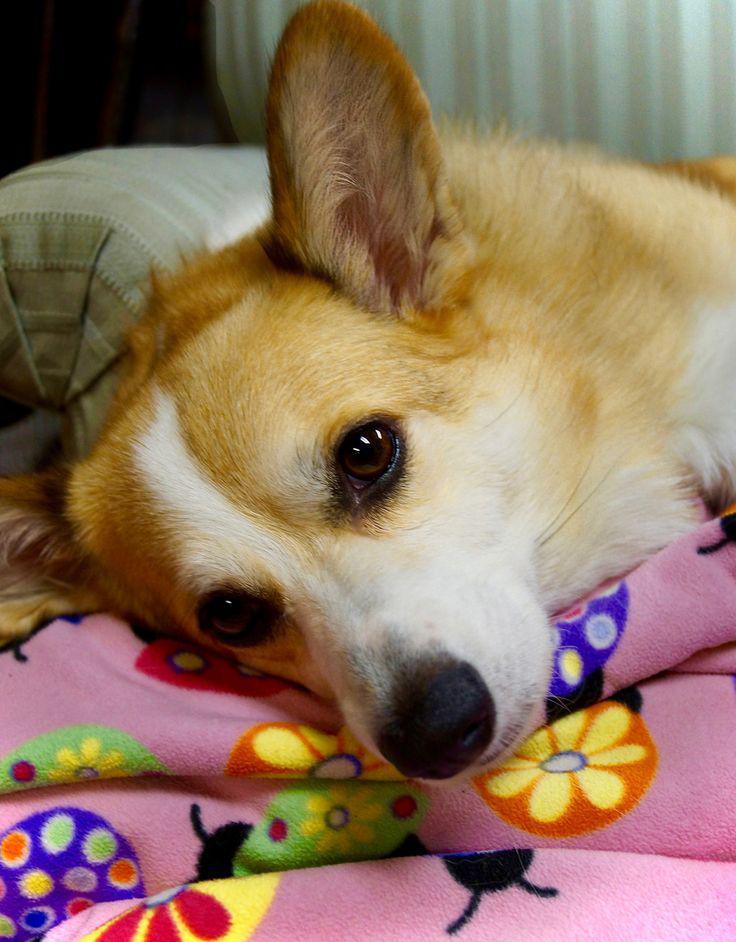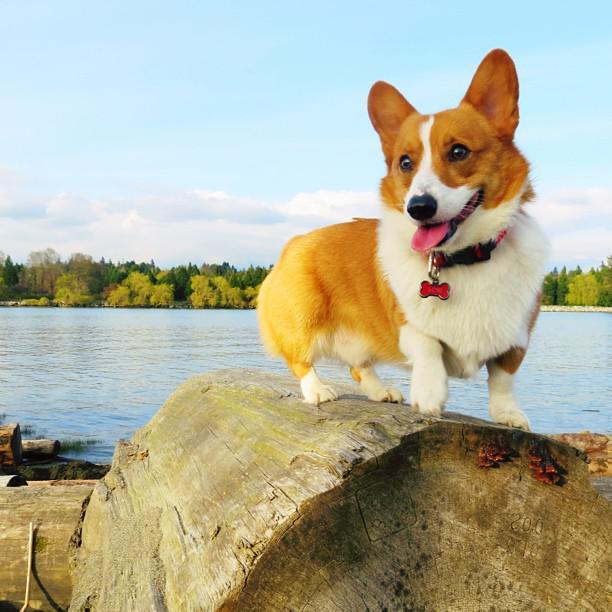The first image is the image on the left, the second image is the image on the right. For the images displayed, is the sentence "All corgis are reclining on wood floors, and at least one corgi has its eyes shut." factually correct? Answer yes or no. No. The first image is the image on the left, the second image is the image on the right. Analyze the images presented: Is the assertion "The left image contains a dog that is laying down inside on a wooden floor." valid? Answer yes or no. No. 